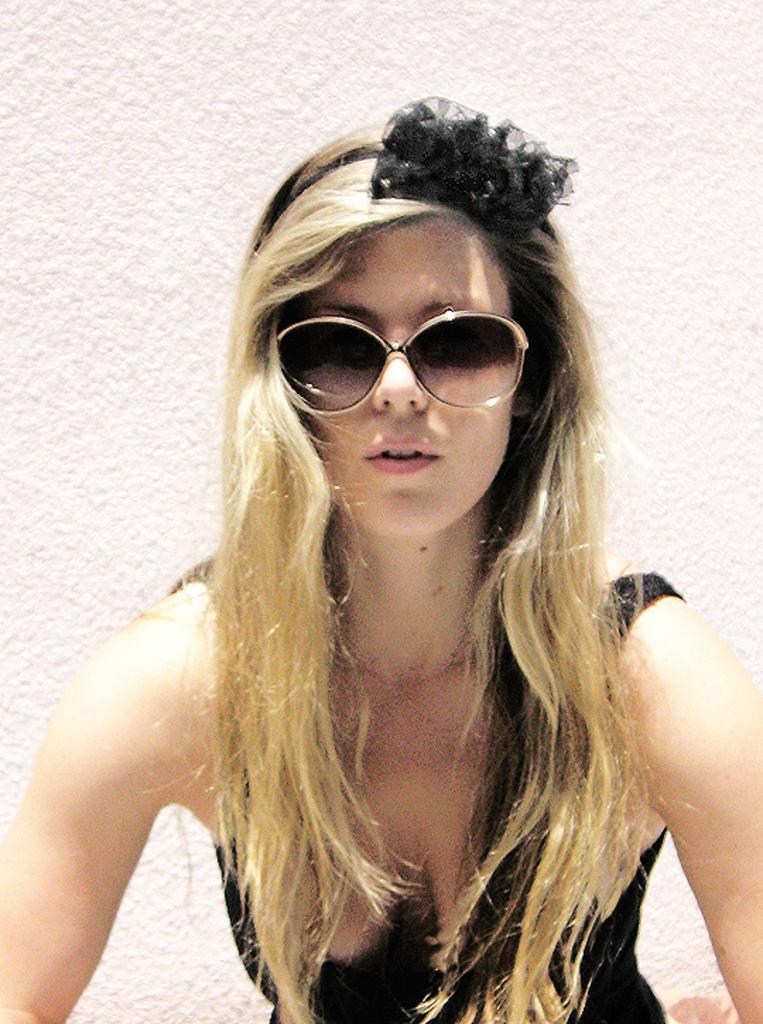In one or two sentences, can you explain what this image depicts? In the image there is a woman with blond hair and black top standing in front of wall, she is wearing glasses. 